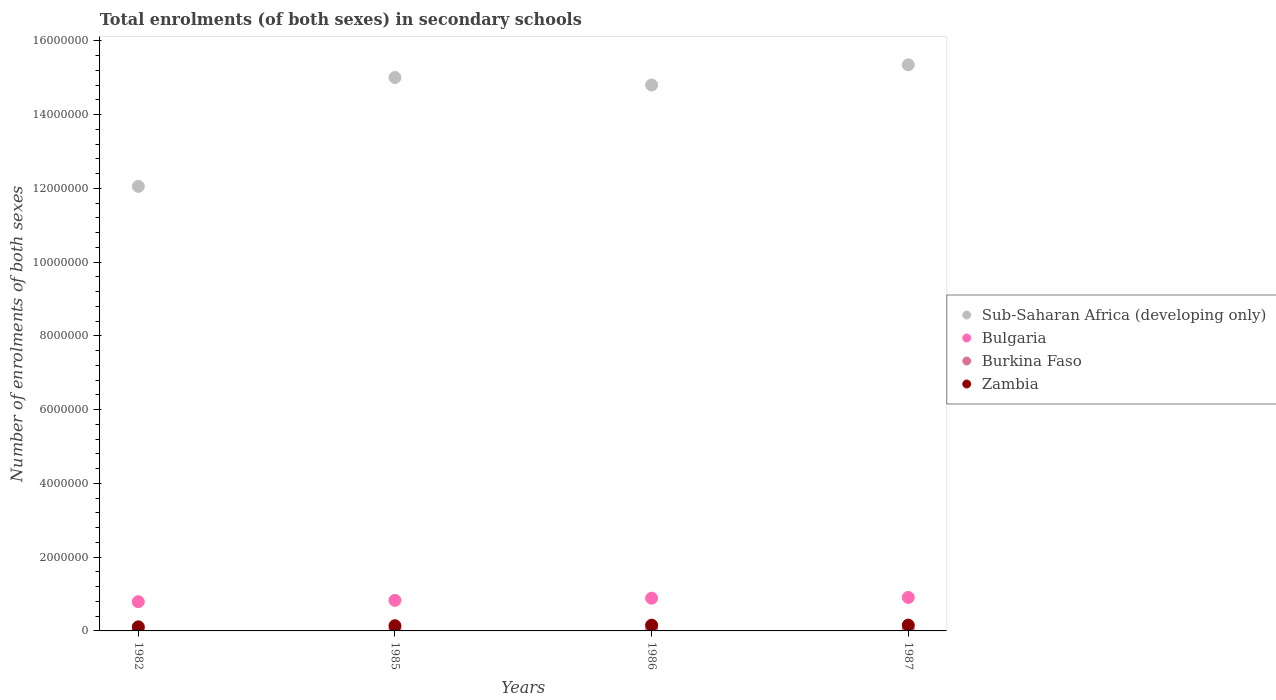How many different coloured dotlines are there?
Provide a succinct answer. 4. What is the number of enrolments in secondary schools in Zambia in 1986?
Make the answer very short. 1.56e+05. Across all years, what is the maximum number of enrolments in secondary schools in Bulgaria?
Your response must be concise. 9.08e+05. Across all years, what is the minimum number of enrolments in secondary schools in Zambia?
Your response must be concise. 1.10e+05. In which year was the number of enrolments in secondary schools in Zambia maximum?
Make the answer very short. 1987. In which year was the number of enrolments in secondary schools in Bulgaria minimum?
Make the answer very short. 1982. What is the total number of enrolments in secondary schools in Zambia in the graph?
Offer a terse response. 5.65e+05. What is the difference between the number of enrolments in secondary schools in Sub-Saharan Africa (developing only) in 1982 and that in 1986?
Ensure brevity in your answer.  -2.75e+06. What is the difference between the number of enrolments in secondary schools in Bulgaria in 1985 and the number of enrolments in secondary schools in Burkina Faso in 1986?
Provide a succinct answer. 7.75e+05. What is the average number of enrolments in secondary schools in Bulgaria per year?
Offer a very short reply. 8.54e+05. In the year 1987, what is the difference between the number of enrolments in secondary schools in Sub-Saharan Africa (developing only) and number of enrolments in secondary schools in Zambia?
Make the answer very short. 1.52e+07. In how many years, is the number of enrolments in secondary schools in Burkina Faso greater than 8000000?
Give a very brief answer. 0. What is the ratio of the number of enrolments in secondary schools in Zambia in 1982 to that in 1985?
Offer a very short reply. 0.78. What is the difference between the highest and the second highest number of enrolments in secondary schools in Sub-Saharan Africa (developing only)?
Provide a succinct answer. 3.44e+05. What is the difference between the highest and the lowest number of enrolments in secondary schools in Zambia?
Keep it short and to the point. 4.78e+04. Is the sum of the number of enrolments in secondary schools in Zambia in 1985 and 1986 greater than the maximum number of enrolments in secondary schools in Burkina Faso across all years?
Make the answer very short. Yes. Is it the case that in every year, the sum of the number of enrolments in secondary schools in Sub-Saharan Africa (developing only) and number of enrolments in secondary schools in Zambia  is greater than the sum of number of enrolments in secondary schools in Burkina Faso and number of enrolments in secondary schools in Bulgaria?
Your answer should be very brief. Yes. Is it the case that in every year, the sum of the number of enrolments in secondary schools in Zambia and number of enrolments in secondary schools in Burkina Faso  is greater than the number of enrolments in secondary schools in Sub-Saharan Africa (developing only)?
Provide a succinct answer. No. Does the number of enrolments in secondary schools in Burkina Faso monotonically increase over the years?
Your answer should be very brief. Yes. How many dotlines are there?
Make the answer very short. 4. Are the values on the major ticks of Y-axis written in scientific E-notation?
Make the answer very short. No. Does the graph contain grids?
Offer a terse response. No. What is the title of the graph?
Make the answer very short. Total enrolments (of both sexes) in secondary schools. Does "Sudan" appear as one of the legend labels in the graph?
Make the answer very short. No. What is the label or title of the Y-axis?
Offer a very short reply. Number of enrolments of both sexes. What is the Number of enrolments of both sexes of Sub-Saharan Africa (developing only) in 1982?
Your response must be concise. 1.21e+07. What is the Number of enrolments of both sexes in Bulgaria in 1982?
Keep it short and to the point. 7.92e+05. What is the Number of enrolments of both sexes of Burkina Faso in 1982?
Give a very brief answer. 3.14e+04. What is the Number of enrolments of both sexes in Zambia in 1982?
Offer a very short reply. 1.10e+05. What is the Number of enrolments of both sexes in Sub-Saharan Africa (developing only) in 1985?
Your response must be concise. 1.50e+07. What is the Number of enrolments of both sexes in Bulgaria in 1985?
Your response must be concise. 8.29e+05. What is the Number of enrolments of both sexes in Burkina Faso in 1985?
Provide a succinct answer. 4.38e+04. What is the Number of enrolments of both sexes in Zambia in 1985?
Your response must be concise. 1.41e+05. What is the Number of enrolments of both sexes in Sub-Saharan Africa (developing only) in 1986?
Keep it short and to the point. 1.48e+07. What is the Number of enrolments of both sexes of Bulgaria in 1986?
Provide a succinct answer. 8.88e+05. What is the Number of enrolments of both sexes of Burkina Faso in 1986?
Provide a short and direct response. 5.36e+04. What is the Number of enrolments of both sexes in Zambia in 1986?
Your answer should be very brief. 1.56e+05. What is the Number of enrolments of both sexes of Sub-Saharan Africa (developing only) in 1987?
Your answer should be very brief. 1.54e+07. What is the Number of enrolments of both sexes in Bulgaria in 1987?
Your answer should be very brief. 9.08e+05. What is the Number of enrolments of both sexes in Burkina Faso in 1987?
Provide a succinct answer. 6.26e+04. What is the Number of enrolments of both sexes of Zambia in 1987?
Keep it short and to the point. 1.58e+05. Across all years, what is the maximum Number of enrolments of both sexes in Sub-Saharan Africa (developing only)?
Keep it short and to the point. 1.54e+07. Across all years, what is the maximum Number of enrolments of both sexes in Bulgaria?
Your answer should be very brief. 9.08e+05. Across all years, what is the maximum Number of enrolments of both sexes of Burkina Faso?
Keep it short and to the point. 6.26e+04. Across all years, what is the maximum Number of enrolments of both sexes in Zambia?
Your answer should be very brief. 1.58e+05. Across all years, what is the minimum Number of enrolments of both sexes in Sub-Saharan Africa (developing only)?
Your answer should be compact. 1.21e+07. Across all years, what is the minimum Number of enrolments of both sexes in Bulgaria?
Your response must be concise. 7.92e+05. Across all years, what is the minimum Number of enrolments of both sexes of Burkina Faso?
Give a very brief answer. 3.14e+04. Across all years, what is the minimum Number of enrolments of both sexes in Zambia?
Offer a very short reply. 1.10e+05. What is the total Number of enrolments of both sexes of Sub-Saharan Africa (developing only) in the graph?
Provide a short and direct response. 5.72e+07. What is the total Number of enrolments of both sexes of Bulgaria in the graph?
Give a very brief answer. 3.42e+06. What is the total Number of enrolments of both sexes in Burkina Faso in the graph?
Provide a succinct answer. 1.91e+05. What is the total Number of enrolments of both sexes in Zambia in the graph?
Make the answer very short. 5.65e+05. What is the difference between the Number of enrolments of both sexes of Sub-Saharan Africa (developing only) in 1982 and that in 1985?
Provide a succinct answer. -2.95e+06. What is the difference between the Number of enrolments of both sexes of Bulgaria in 1982 and that in 1985?
Your answer should be compact. -3.64e+04. What is the difference between the Number of enrolments of both sexes of Burkina Faso in 1982 and that in 1985?
Your answer should be compact. -1.24e+04. What is the difference between the Number of enrolments of both sexes in Zambia in 1982 and that in 1985?
Your answer should be compact. -3.03e+04. What is the difference between the Number of enrolments of both sexes of Sub-Saharan Africa (developing only) in 1982 and that in 1986?
Make the answer very short. -2.75e+06. What is the difference between the Number of enrolments of both sexes of Bulgaria in 1982 and that in 1986?
Make the answer very short. -9.56e+04. What is the difference between the Number of enrolments of both sexes in Burkina Faso in 1982 and that in 1986?
Keep it short and to the point. -2.22e+04. What is the difference between the Number of enrolments of both sexes in Zambia in 1982 and that in 1986?
Ensure brevity in your answer.  -4.57e+04. What is the difference between the Number of enrolments of both sexes of Sub-Saharan Africa (developing only) in 1982 and that in 1987?
Offer a very short reply. -3.30e+06. What is the difference between the Number of enrolments of both sexes in Bulgaria in 1982 and that in 1987?
Your answer should be compact. -1.15e+05. What is the difference between the Number of enrolments of both sexes of Burkina Faso in 1982 and that in 1987?
Give a very brief answer. -3.12e+04. What is the difference between the Number of enrolments of both sexes in Zambia in 1982 and that in 1987?
Provide a succinct answer. -4.78e+04. What is the difference between the Number of enrolments of both sexes of Sub-Saharan Africa (developing only) in 1985 and that in 1986?
Ensure brevity in your answer.  2.04e+05. What is the difference between the Number of enrolments of both sexes of Bulgaria in 1985 and that in 1986?
Your answer should be very brief. -5.92e+04. What is the difference between the Number of enrolments of both sexes of Burkina Faso in 1985 and that in 1986?
Keep it short and to the point. -9722. What is the difference between the Number of enrolments of both sexes of Zambia in 1985 and that in 1986?
Offer a terse response. -1.53e+04. What is the difference between the Number of enrolments of both sexes of Sub-Saharan Africa (developing only) in 1985 and that in 1987?
Ensure brevity in your answer.  -3.44e+05. What is the difference between the Number of enrolments of both sexes of Bulgaria in 1985 and that in 1987?
Offer a very short reply. -7.89e+04. What is the difference between the Number of enrolments of both sexes in Burkina Faso in 1985 and that in 1987?
Your answer should be very brief. -1.87e+04. What is the difference between the Number of enrolments of both sexes of Zambia in 1985 and that in 1987?
Make the answer very short. -1.74e+04. What is the difference between the Number of enrolments of both sexes of Sub-Saharan Africa (developing only) in 1986 and that in 1987?
Keep it short and to the point. -5.48e+05. What is the difference between the Number of enrolments of both sexes in Bulgaria in 1986 and that in 1987?
Give a very brief answer. -1.97e+04. What is the difference between the Number of enrolments of both sexes of Burkina Faso in 1986 and that in 1987?
Your answer should be very brief. -9017. What is the difference between the Number of enrolments of both sexes of Zambia in 1986 and that in 1987?
Keep it short and to the point. -2080. What is the difference between the Number of enrolments of both sexes of Sub-Saharan Africa (developing only) in 1982 and the Number of enrolments of both sexes of Bulgaria in 1985?
Offer a very short reply. 1.12e+07. What is the difference between the Number of enrolments of both sexes in Sub-Saharan Africa (developing only) in 1982 and the Number of enrolments of both sexes in Burkina Faso in 1985?
Offer a very short reply. 1.20e+07. What is the difference between the Number of enrolments of both sexes in Sub-Saharan Africa (developing only) in 1982 and the Number of enrolments of both sexes in Zambia in 1985?
Your response must be concise. 1.19e+07. What is the difference between the Number of enrolments of both sexes of Bulgaria in 1982 and the Number of enrolments of both sexes of Burkina Faso in 1985?
Offer a terse response. 7.48e+05. What is the difference between the Number of enrolments of both sexes of Bulgaria in 1982 and the Number of enrolments of both sexes of Zambia in 1985?
Provide a succinct answer. 6.52e+05. What is the difference between the Number of enrolments of both sexes of Burkina Faso in 1982 and the Number of enrolments of both sexes of Zambia in 1985?
Offer a terse response. -1.09e+05. What is the difference between the Number of enrolments of both sexes of Sub-Saharan Africa (developing only) in 1982 and the Number of enrolments of both sexes of Bulgaria in 1986?
Keep it short and to the point. 1.12e+07. What is the difference between the Number of enrolments of both sexes in Sub-Saharan Africa (developing only) in 1982 and the Number of enrolments of both sexes in Burkina Faso in 1986?
Your answer should be very brief. 1.20e+07. What is the difference between the Number of enrolments of both sexes of Sub-Saharan Africa (developing only) in 1982 and the Number of enrolments of both sexes of Zambia in 1986?
Your answer should be very brief. 1.19e+07. What is the difference between the Number of enrolments of both sexes in Bulgaria in 1982 and the Number of enrolments of both sexes in Burkina Faso in 1986?
Provide a short and direct response. 7.39e+05. What is the difference between the Number of enrolments of both sexes in Bulgaria in 1982 and the Number of enrolments of both sexes in Zambia in 1986?
Your response must be concise. 6.36e+05. What is the difference between the Number of enrolments of both sexes in Burkina Faso in 1982 and the Number of enrolments of both sexes in Zambia in 1986?
Provide a short and direct response. -1.25e+05. What is the difference between the Number of enrolments of both sexes in Sub-Saharan Africa (developing only) in 1982 and the Number of enrolments of both sexes in Bulgaria in 1987?
Give a very brief answer. 1.11e+07. What is the difference between the Number of enrolments of both sexes in Sub-Saharan Africa (developing only) in 1982 and the Number of enrolments of both sexes in Burkina Faso in 1987?
Make the answer very short. 1.20e+07. What is the difference between the Number of enrolments of both sexes in Sub-Saharan Africa (developing only) in 1982 and the Number of enrolments of both sexes in Zambia in 1987?
Offer a very short reply. 1.19e+07. What is the difference between the Number of enrolments of both sexes of Bulgaria in 1982 and the Number of enrolments of both sexes of Burkina Faso in 1987?
Ensure brevity in your answer.  7.30e+05. What is the difference between the Number of enrolments of both sexes in Bulgaria in 1982 and the Number of enrolments of both sexes in Zambia in 1987?
Provide a short and direct response. 6.34e+05. What is the difference between the Number of enrolments of both sexes in Burkina Faso in 1982 and the Number of enrolments of both sexes in Zambia in 1987?
Make the answer very short. -1.27e+05. What is the difference between the Number of enrolments of both sexes in Sub-Saharan Africa (developing only) in 1985 and the Number of enrolments of both sexes in Bulgaria in 1986?
Offer a very short reply. 1.41e+07. What is the difference between the Number of enrolments of both sexes of Sub-Saharan Africa (developing only) in 1985 and the Number of enrolments of both sexes of Burkina Faso in 1986?
Your response must be concise. 1.50e+07. What is the difference between the Number of enrolments of both sexes in Sub-Saharan Africa (developing only) in 1985 and the Number of enrolments of both sexes in Zambia in 1986?
Ensure brevity in your answer.  1.49e+07. What is the difference between the Number of enrolments of both sexes of Bulgaria in 1985 and the Number of enrolments of both sexes of Burkina Faso in 1986?
Offer a very short reply. 7.75e+05. What is the difference between the Number of enrolments of both sexes of Bulgaria in 1985 and the Number of enrolments of both sexes of Zambia in 1986?
Provide a succinct answer. 6.73e+05. What is the difference between the Number of enrolments of both sexes in Burkina Faso in 1985 and the Number of enrolments of both sexes in Zambia in 1986?
Make the answer very short. -1.12e+05. What is the difference between the Number of enrolments of both sexes of Sub-Saharan Africa (developing only) in 1985 and the Number of enrolments of both sexes of Bulgaria in 1987?
Offer a very short reply. 1.41e+07. What is the difference between the Number of enrolments of both sexes of Sub-Saharan Africa (developing only) in 1985 and the Number of enrolments of both sexes of Burkina Faso in 1987?
Offer a terse response. 1.49e+07. What is the difference between the Number of enrolments of both sexes in Sub-Saharan Africa (developing only) in 1985 and the Number of enrolments of both sexes in Zambia in 1987?
Your answer should be compact. 1.48e+07. What is the difference between the Number of enrolments of both sexes of Bulgaria in 1985 and the Number of enrolments of both sexes of Burkina Faso in 1987?
Your answer should be very brief. 7.66e+05. What is the difference between the Number of enrolments of both sexes in Bulgaria in 1985 and the Number of enrolments of both sexes in Zambia in 1987?
Offer a very short reply. 6.71e+05. What is the difference between the Number of enrolments of both sexes in Burkina Faso in 1985 and the Number of enrolments of both sexes in Zambia in 1987?
Your response must be concise. -1.14e+05. What is the difference between the Number of enrolments of both sexes of Sub-Saharan Africa (developing only) in 1986 and the Number of enrolments of both sexes of Bulgaria in 1987?
Provide a succinct answer. 1.39e+07. What is the difference between the Number of enrolments of both sexes of Sub-Saharan Africa (developing only) in 1986 and the Number of enrolments of both sexes of Burkina Faso in 1987?
Your answer should be very brief. 1.47e+07. What is the difference between the Number of enrolments of both sexes in Sub-Saharan Africa (developing only) in 1986 and the Number of enrolments of both sexes in Zambia in 1987?
Offer a very short reply. 1.46e+07. What is the difference between the Number of enrolments of both sexes of Bulgaria in 1986 and the Number of enrolments of both sexes of Burkina Faso in 1987?
Offer a very short reply. 8.25e+05. What is the difference between the Number of enrolments of both sexes of Bulgaria in 1986 and the Number of enrolments of both sexes of Zambia in 1987?
Offer a very short reply. 7.30e+05. What is the difference between the Number of enrolments of both sexes in Burkina Faso in 1986 and the Number of enrolments of both sexes in Zambia in 1987?
Give a very brief answer. -1.05e+05. What is the average Number of enrolments of both sexes in Sub-Saharan Africa (developing only) per year?
Keep it short and to the point. 1.43e+07. What is the average Number of enrolments of both sexes in Bulgaria per year?
Provide a short and direct response. 8.54e+05. What is the average Number of enrolments of both sexes of Burkina Faso per year?
Keep it short and to the point. 4.78e+04. What is the average Number of enrolments of both sexes of Zambia per year?
Make the answer very short. 1.41e+05. In the year 1982, what is the difference between the Number of enrolments of both sexes of Sub-Saharan Africa (developing only) and Number of enrolments of both sexes of Bulgaria?
Provide a succinct answer. 1.13e+07. In the year 1982, what is the difference between the Number of enrolments of both sexes in Sub-Saharan Africa (developing only) and Number of enrolments of both sexes in Burkina Faso?
Make the answer very short. 1.20e+07. In the year 1982, what is the difference between the Number of enrolments of both sexes in Sub-Saharan Africa (developing only) and Number of enrolments of both sexes in Zambia?
Provide a short and direct response. 1.19e+07. In the year 1982, what is the difference between the Number of enrolments of both sexes of Bulgaria and Number of enrolments of both sexes of Burkina Faso?
Make the answer very short. 7.61e+05. In the year 1982, what is the difference between the Number of enrolments of both sexes of Bulgaria and Number of enrolments of both sexes of Zambia?
Your response must be concise. 6.82e+05. In the year 1982, what is the difference between the Number of enrolments of both sexes of Burkina Faso and Number of enrolments of both sexes of Zambia?
Keep it short and to the point. -7.90e+04. In the year 1985, what is the difference between the Number of enrolments of both sexes in Sub-Saharan Africa (developing only) and Number of enrolments of both sexes in Bulgaria?
Offer a very short reply. 1.42e+07. In the year 1985, what is the difference between the Number of enrolments of both sexes of Sub-Saharan Africa (developing only) and Number of enrolments of both sexes of Burkina Faso?
Your answer should be compact. 1.50e+07. In the year 1985, what is the difference between the Number of enrolments of both sexes in Sub-Saharan Africa (developing only) and Number of enrolments of both sexes in Zambia?
Give a very brief answer. 1.49e+07. In the year 1985, what is the difference between the Number of enrolments of both sexes in Bulgaria and Number of enrolments of both sexes in Burkina Faso?
Offer a terse response. 7.85e+05. In the year 1985, what is the difference between the Number of enrolments of both sexes in Bulgaria and Number of enrolments of both sexes in Zambia?
Offer a terse response. 6.88e+05. In the year 1985, what is the difference between the Number of enrolments of both sexes in Burkina Faso and Number of enrolments of both sexes in Zambia?
Offer a very short reply. -9.69e+04. In the year 1986, what is the difference between the Number of enrolments of both sexes in Sub-Saharan Africa (developing only) and Number of enrolments of both sexes in Bulgaria?
Provide a short and direct response. 1.39e+07. In the year 1986, what is the difference between the Number of enrolments of both sexes of Sub-Saharan Africa (developing only) and Number of enrolments of both sexes of Burkina Faso?
Give a very brief answer. 1.48e+07. In the year 1986, what is the difference between the Number of enrolments of both sexes in Sub-Saharan Africa (developing only) and Number of enrolments of both sexes in Zambia?
Ensure brevity in your answer.  1.46e+07. In the year 1986, what is the difference between the Number of enrolments of both sexes of Bulgaria and Number of enrolments of both sexes of Burkina Faso?
Your answer should be very brief. 8.34e+05. In the year 1986, what is the difference between the Number of enrolments of both sexes in Bulgaria and Number of enrolments of both sexes in Zambia?
Provide a succinct answer. 7.32e+05. In the year 1986, what is the difference between the Number of enrolments of both sexes of Burkina Faso and Number of enrolments of both sexes of Zambia?
Your answer should be very brief. -1.03e+05. In the year 1987, what is the difference between the Number of enrolments of both sexes of Sub-Saharan Africa (developing only) and Number of enrolments of both sexes of Bulgaria?
Make the answer very short. 1.44e+07. In the year 1987, what is the difference between the Number of enrolments of both sexes of Sub-Saharan Africa (developing only) and Number of enrolments of both sexes of Burkina Faso?
Provide a succinct answer. 1.53e+07. In the year 1987, what is the difference between the Number of enrolments of both sexes of Sub-Saharan Africa (developing only) and Number of enrolments of both sexes of Zambia?
Ensure brevity in your answer.  1.52e+07. In the year 1987, what is the difference between the Number of enrolments of both sexes in Bulgaria and Number of enrolments of both sexes in Burkina Faso?
Your answer should be very brief. 8.45e+05. In the year 1987, what is the difference between the Number of enrolments of both sexes in Bulgaria and Number of enrolments of both sexes in Zambia?
Your answer should be very brief. 7.49e+05. In the year 1987, what is the difference between the Number of enrolments of both sexes in Burkina Faso and Number of enrolments of both sexes in Zambia?
Provide a short and direct response. -9.56e+04. What is the ratio of the Number of enrolments of both sexes in Sub-Saharan Africa (developing only) in 1982 to that in 1985?
Ensure brevity in your answer.  0.8. What is the ratio of the Number of enrolments of both sexes of Bulgaria in 1982 to that in 1985?
Give a very brief answer. 0.96. What is the ratio of the Number of enrolments of both sexes of Burkina Faso in 1982 to that in 1985?
Provide a short and direct response. 0.72. What is the ratio of the Number of enrolments of both sexes of Zambia in 1982 to that in 1985?
Provide a succinct answer. 0.78. What is the ratio of the Number of enrolments of both sexes in Sub-Saharan Africa (developing only) in 1982 to that in 1986?
Your response must be concise. 0.81. What is the ratio of the Number of enrolments of both sexes of Bulgaria in 1982 to that in 1986?
Give a very brief answer. 0.89. What is the ratio of the Number of enrolments of both sexes in Burkina Faso in 1982 to that in 1986?
Provide a succinct answer. 0.59. What is the ratio of the Number of enrolments of both sexes in Zambia in 1982 to that in 1986?
Offer a very short reply. 0.71. What is the ratio of the Number of enrolments of both sexes of Sub-Saharan Africa (developing only) in 1982 to that in 1987?
Offer a very short reply. 0.79. What is the ratio of the Number of enrolments of both sexes of Bulgaria in 1982 to that in 1987?
Make the answer very short. 0.87. What is the ratio of the Number of enrolments of both sexes in Burkina Faso in 1982 to that in 1987?
Provide a succinct answer. 0.5. What is the ratio of the Number of enrolments of both sexes in Zambia in 1982 to that in 1987?
Provide a short and direct response. 0.7. What is the ratio of the Number of enrolments of both sexes of Sub-Saharan Africa (developing only) in 1985 to that in 1986?
Offer a very short reply. 1.01. What is the ratio of the Number of enrolments of both sexes of Burkina Faso in 1985 to that in 1986?
Your answer should be compact. 0.82. What is the ratio of the Number of enrolments of both sexes in Zambia in 1985 to that in 1986?
Your answer should be very brief. 0.9. What is the ratio of the Number of enrolments of both sexes in Sub-Saharan Africa (developing only) in 1985 to that in 1987?
Keep it short and to the point. 0.98. What is the ratio of the Number of enrolments of both sexes in Bulgaria in 1985 to that in 1987?
Give a very brief answer. 0.91. What is the ratio of the Number of enrolments of both sexes of Burkina Faso in 1985 to that in 1987?
Provide a succinct answer. 0.7. What is the ratio of the Number of enrolments of both sexes of Zambia in 1985 to that in 1987?
Offer a terse response. 0.89. What is the ratio of the Number of enrolments of both sexes in Sub-Saharan Africa (developing only) in 1986 to that in 1987?
Give a very brief answer. 0.96. What is the ratio of the Number of enrolments of both sexes of Bulgaria in 1986 to that in 1987?
Offer a terse response. 0.98. What is the ratio of the Number of enrolments of both sexes in Burkina Faso in 1986 to that in 1987?
Your response must be concise. 0.86. What is the difference between the highest and the second highest Number of enrolments of both sexes of Sub-Saharan Africa (developing only)?
Make the answer very short. 3.44e+05. What is the difference between the highest and the second highest Number of enrolments of both sexes of Bulgaria?
Give a very brief answer. 1.97e+04. What is the difference between the highest and the second highest Number of enrolments of both sexes in Burkina Faso?
Your answer should be very brief. 9017. What is the difference between the highest and the second highest Number of enrolments of both sexes of Zambia?
Keep it short and to the point. 2080. What is the difference between the highest and the lowest Number of enrolments of both sexes in Sub-Saharan Africa (developing only)?
Ensure brevity in your answer.  3.30e+06. What is the difference between the highest and the lowest Number of enrolments of both sexes in Bulgaria?
Offer a very short reply. 1.15e+05. What is the difference between the highest and the lowest Number of enrolments of both sexes in Burkina Faso?
Make the answer very short. 3.12e+04. What is the difference between the highest and the lowest Number of enrolments of both sexes of Zambia?
Give a very brief answer. 4.78e+04. 